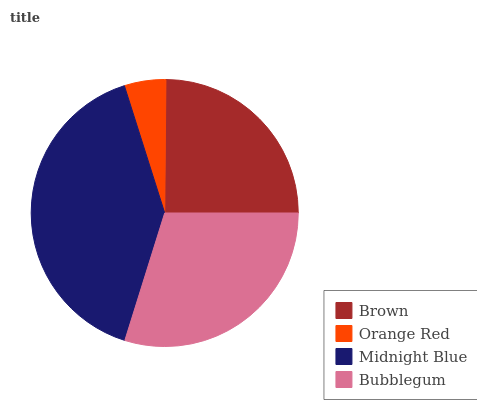Is Orange Red the minimum?
Answer yes or no. Yes. Is Midnight Blue the maximum?
Answer yes or no. Yes. Is Midnight Blue the minimum?
Answer yes or no. No. Is Orange Red the maximum?
Answer yes or no. No. Is Midnight Blue greater than Orange Red?
Answer yes or no. Yes. Is Orange Red less than Midnight Blue?
Answer yes or no. Yes. Is Orange Red greater than Midnight Blue?
Answer yes or no. No. Is Midnight Blue less than Orange Red?
Answer yes or no. No. Is Bubblegum the high median?
Answer yes or no. Yes. Is Brown the low median?
Answer yes or no. Yes. Is Orange Red the high median?
Answer yes or no. No. Is Orange Red the low median?
Answer yes or no. No. 